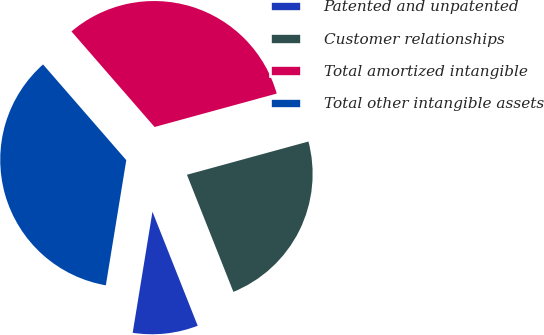Convert chart. <chart><loc_0><loc_0><loc_500><loc_500><pie_chart><fcel>Patented and unpatented<fcel>Customer relationships<fcel>Total amortized intangible<fcel>Total other intangible assets<nl><fcel>8.59%<fcel>23.24%<fcel>32.14%<fcel>36.03%<nl></chart> 